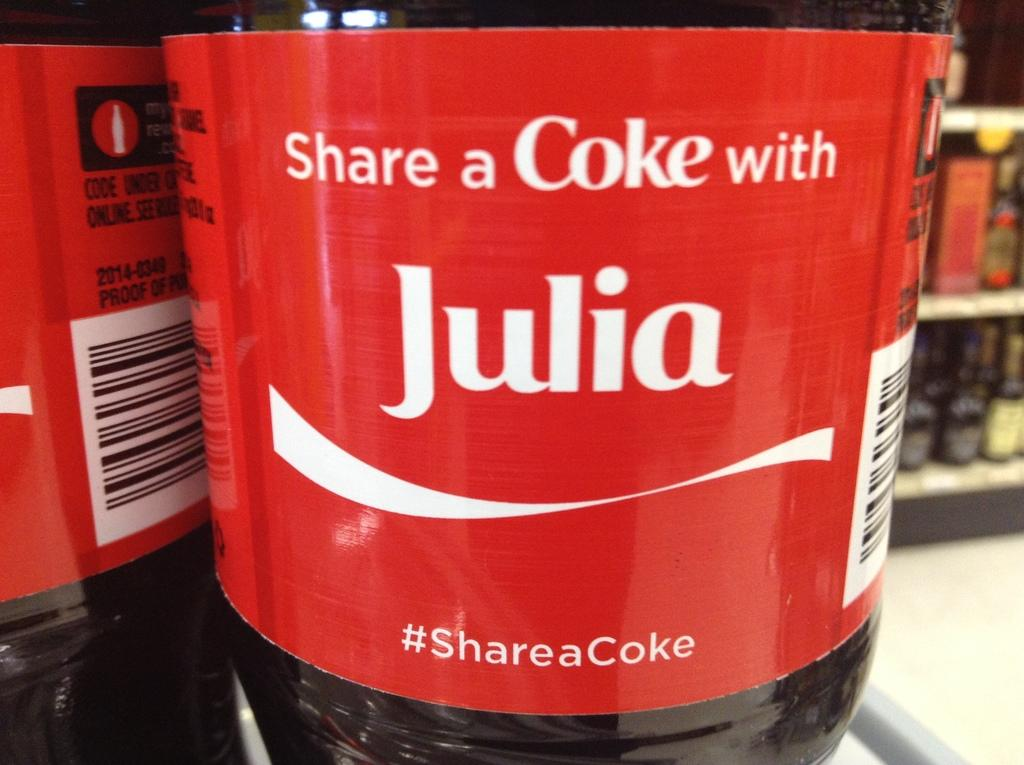<image>
Write a terse but informative summary of the picture. A Coke bottle red label that says Share a Coke with Julia, plus #ShareaCoke. 